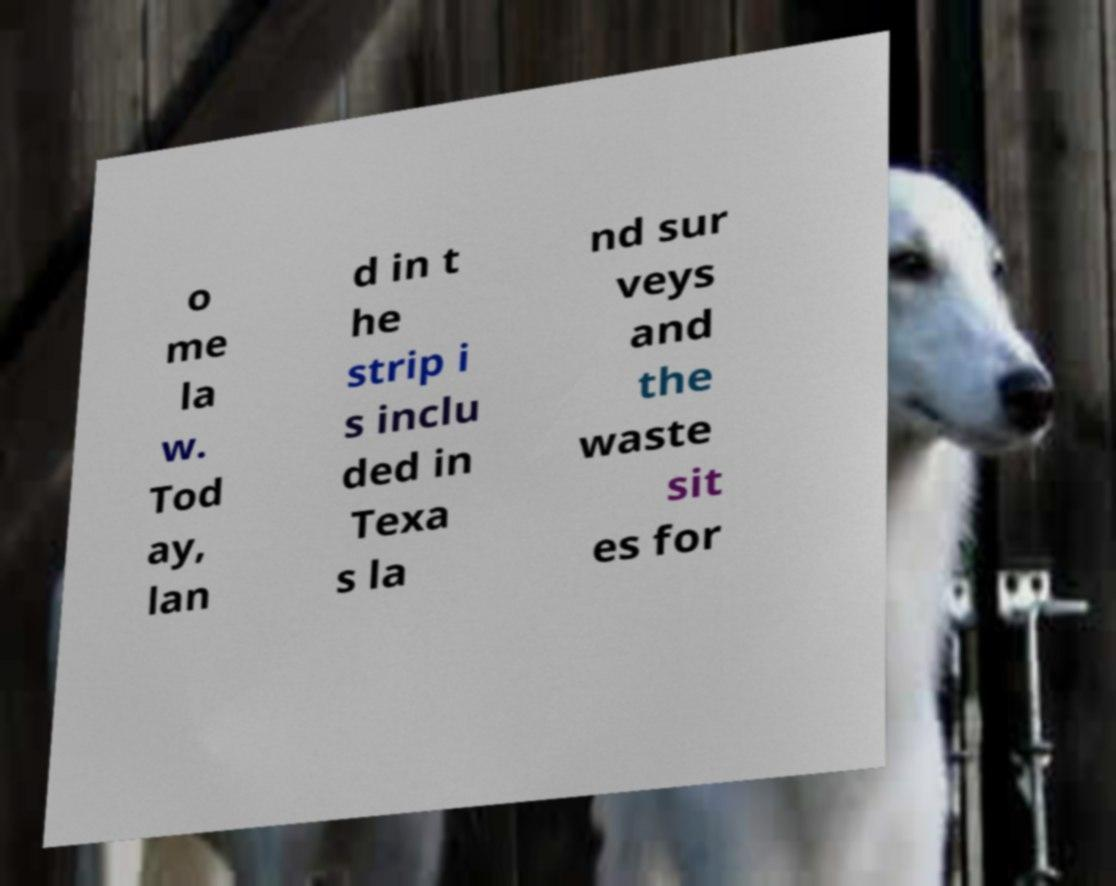Please read and relay the text visible in this image. What does it say? o me la w. Tod ay, lan d in t he strip i s inclu ded in Texa s la nd sur veys and the waste sit es for 